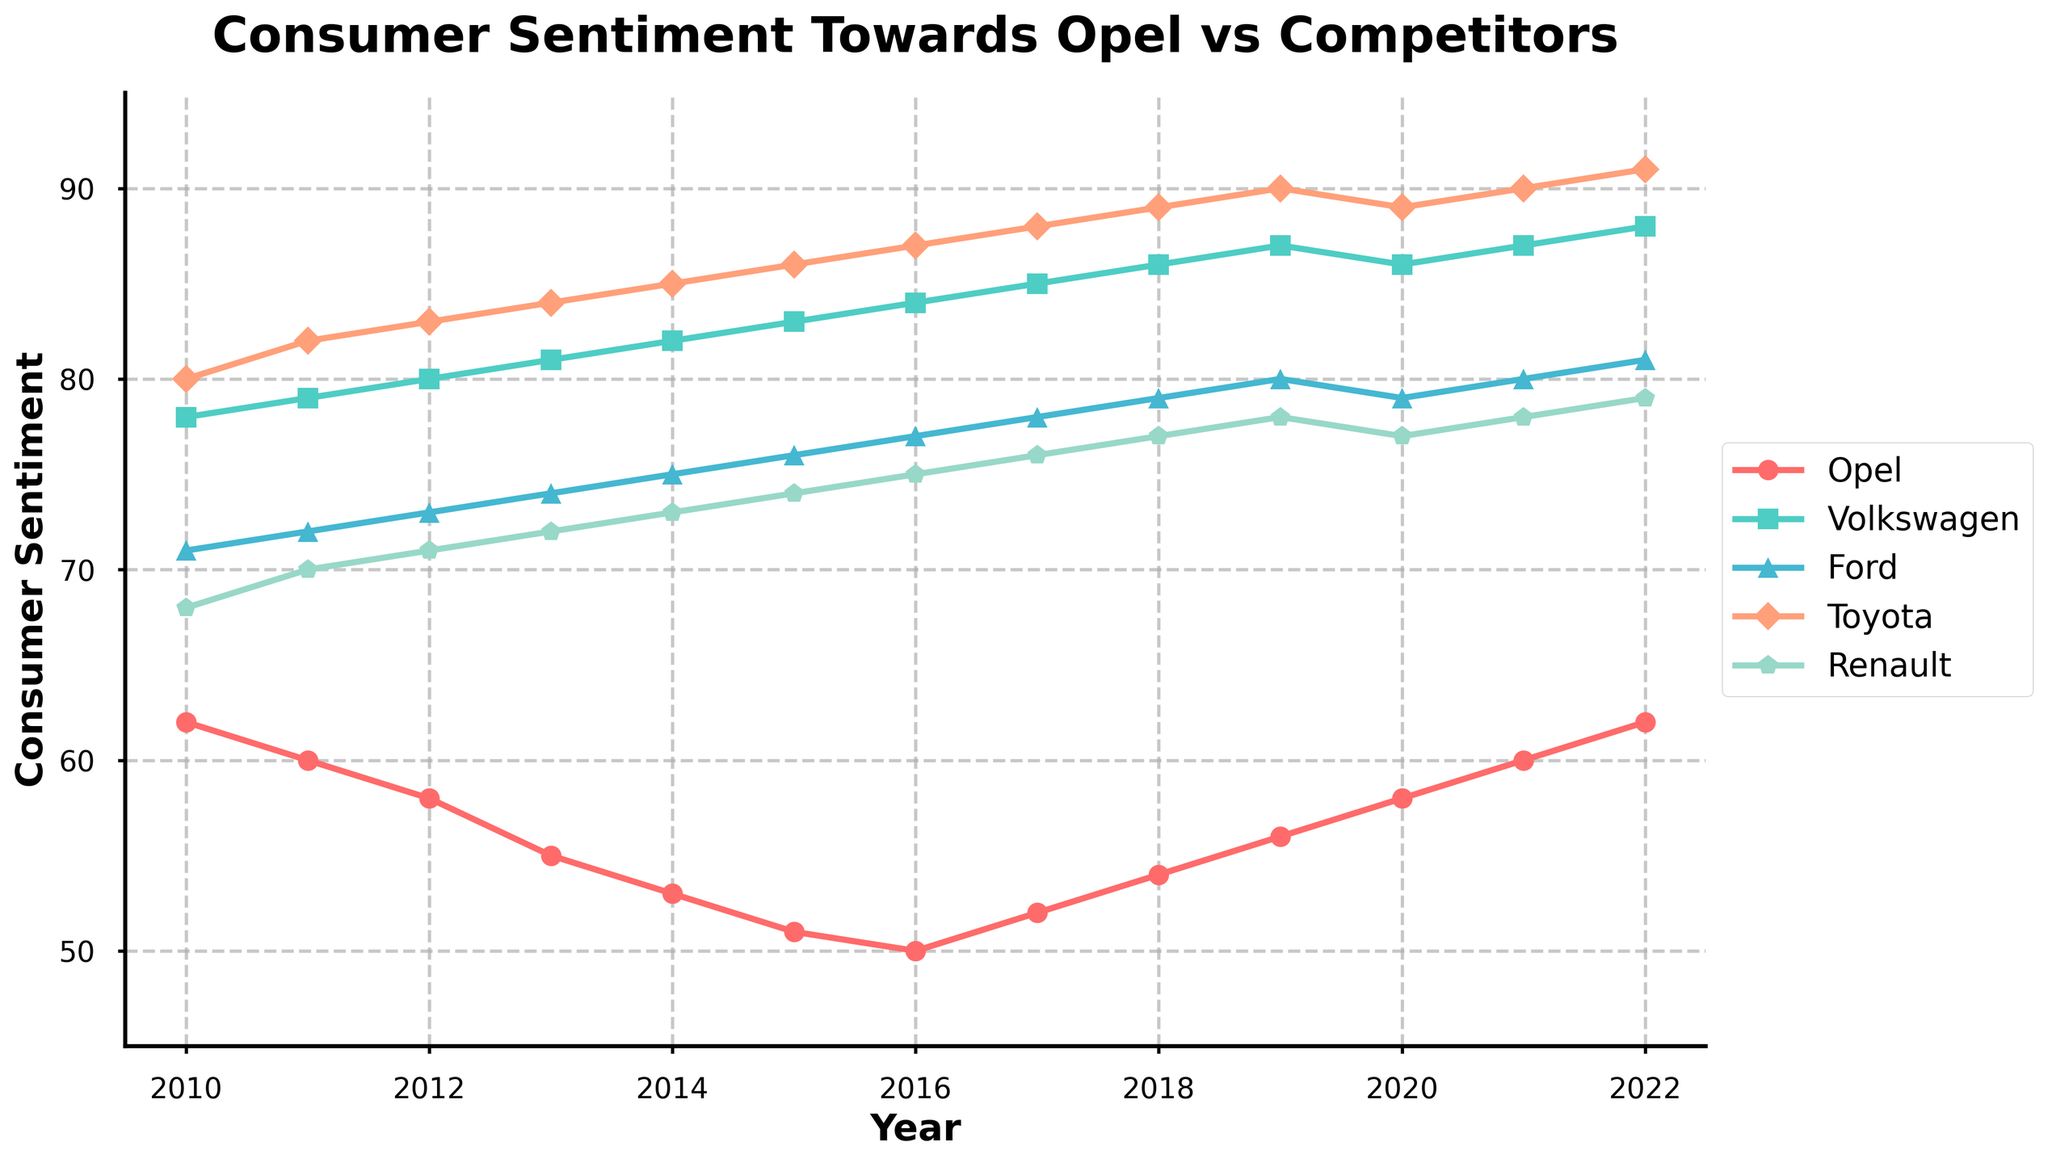What was the trend for consumer sentiment towards Opel from 2010 to 2015? From 2010 to 2015, the consumer sentiment towards Opel consistently decreased each year. In 2010, the sentiment index for Opel was 62, and it gradually reduced to 51 by 2015. This indicates a downward trend in consumer sentiment for Opel during this period.
Answer: Decreasing Which brand showed the highest consumer sentiment in 2020? In 2020, Toyota and Volkswagen had a consumer sentiment index of 89. No other brand had a higher sentiment index that year, indicating both Toyota and Volkswagen had the highest consumer sentiment in 2020.
Answer: Toyota and Volkswagen How did Opel's sentiment in 2017 compare to that in 2012? In 2012, the consumer sentiment for Opel was 58. In 2017, the sentiment increased to 52. This comparison indicates that Opel's sentiment was lower in 2017 than in 2012.
Answer: Lower What is the difference between the highest and lowest consumer sentiment values in 2022? Looking at the consumer sentiment values in 2022, the highest value is 91 (Toyota), and the lowest value is 62 (Opel). The difference is calculated as 91 - 62.
Answer: 29 Between which years did Opel experience the most significant increase in consumer sentiment? Between 2016 and 2017, Opel's consumer sentiment increased from 50 to 52, marking a 2-point rise. This is the largest positive change observed in any single year within the given data for Opel.
Answer: 2016 to 2017 What visual attribute is used to distinguish between different brands on the line chart? Each brand is distinguished using different colors and markers on the line chart. This visual differentiation makes it easier to identify and compare trends for each brand.
Answer: Colors and markers In terms of the overall trend from 2010 to 2022, how does Opel's consumer sentiment compare to Toyota's? From 2010 to 2022, Opel's consumer sentiment experienced an overall decline with a slight upward trend towards the end, whereas Toyota consistently had high and slightly increasing sentiment values. The overall trend for Toyota shows a more stable and positive sentiment compared to Opel's more variable and generally lower sentiment.
Answer: Opel: Decreasing, Toyota: Stable/Increasing 